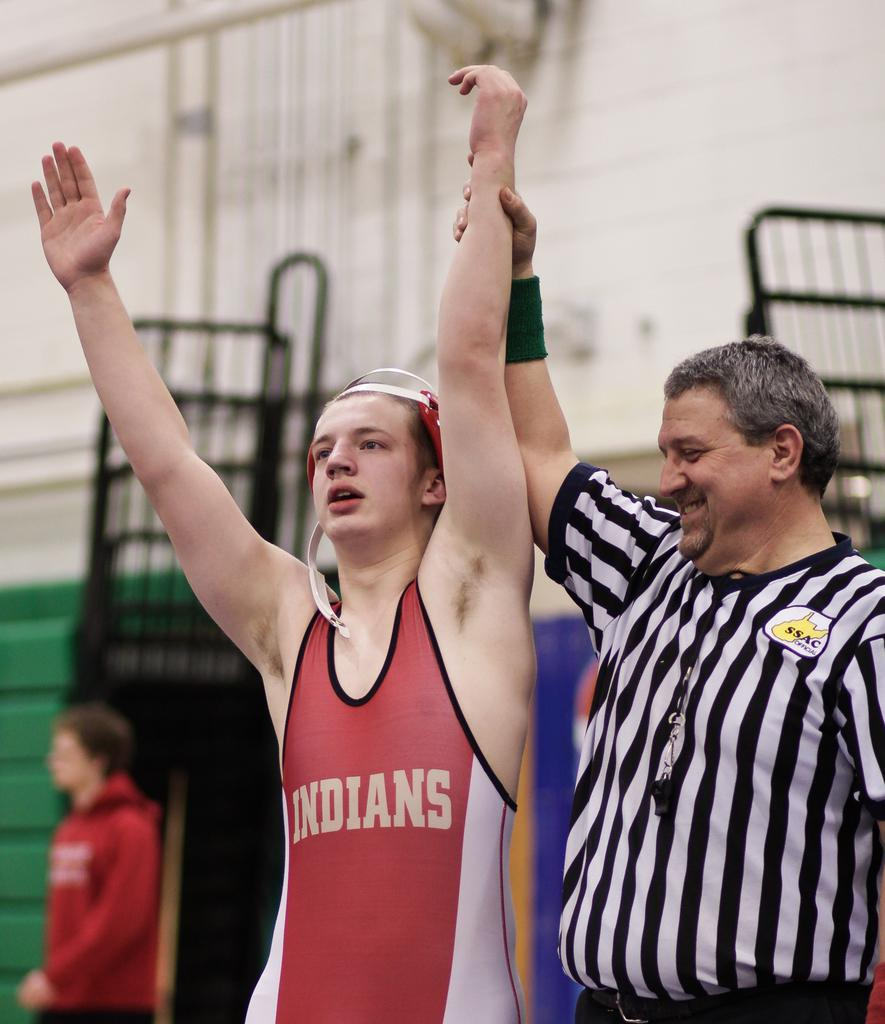<image>
Create a compact narrative representing the image presented. A referee holds up the arm of a wrestler on the Indians' team. 